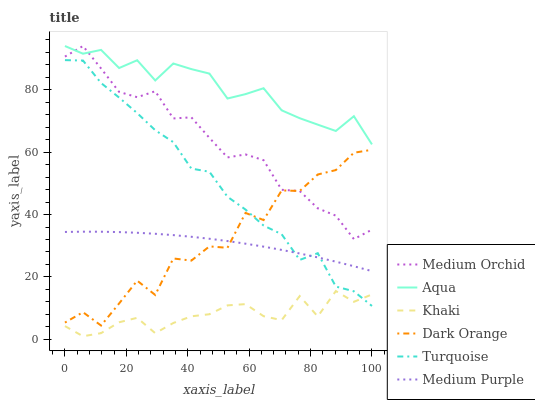Does Khaki have the minimum area under the curve?
Answer yes or no. Yes. Does Aqua have the maximum area under the curve?
Answer yes or no. Yes. Does Turquoise have the minimum area under the curve?
Answer yes or no. No. Does Turquoise have the maximum area under the curve?
Answer yes or no. No. Is Medium Purple the smoothest?
Answer yes or no. Yes. Is Dark Orange the roughest?
Answer yes or no. Yes. Is Turquoise the smoothest?
Answer yes or no. No. Is Turquoise the roughest?
Answer yes or no. No. Does Khaki have the lowest value?
Answer yes or no. Yes. Does Turquoise have the lowest value?
Answer yes or no. No. Does Aqua have the highest value?
Answer yes or no. Yes. Does Turquoise have the highest value?
Answer yes or no. No. Is Turquoise less than Medium Orchid?
Answer yes or no. Yes. Is Aqua greater than Turquoise?
Answer yes or no. Yes. Does Turquoise intersect Dark Orange?
Answer yes or no. Yes. Is Turquoise less than Dark Orange?
Answer yes or no. No. Is Turquoise greater than Dark Orange?
Answer yes or no. No. Does Turquoise intersect Medium Orchid?
Answer yes or no. No. 